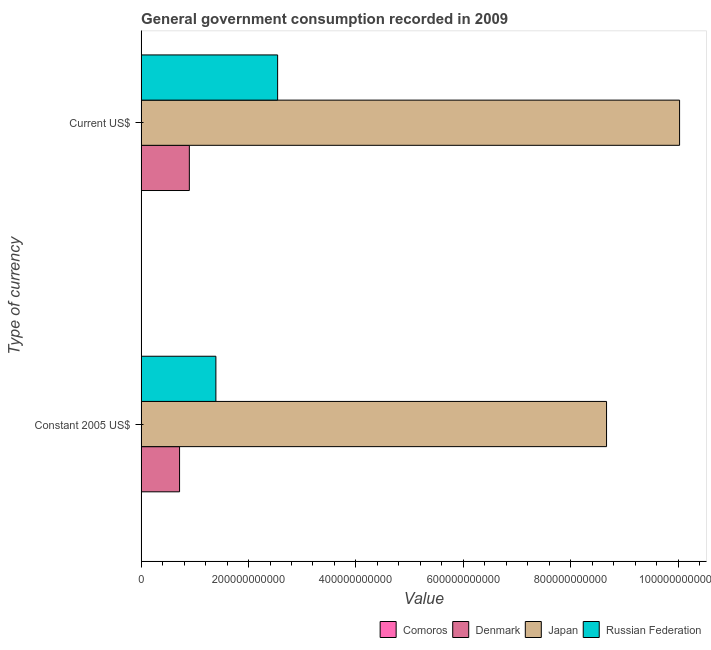How many different coloured bars are there?
Keep it short and to the point. 4. Are the number of bars on each tick of the Y-axis equal?
Your answer should be compact. Yes. How many bars are there on the 1st tick from the top?
Offer a very short reply. 4. How many bars are there on the 1st tick from the bottom?
Your response must be concise. 4. What is the label of the 2nd group of bars from the top?
Your answer should be compact. Constant 2005 US$. What is the value consumed in current us$ in Comoros?
Keep it short and to the point. 8.52e+07. Across all countries, what is the maximum value consumed in current us$?
Your response must be concise. 1.00e+12. Across all countries, what is the minimum value consumed in constant 2005 us$?
Give a very brief answer. 8.08e+07. In which country was the value consumed in current us$ minimum?
Offer a very short reply. Comoros. What is the total value consumed in constant 2005 us$ in the graph?
Offer a terse response. 1.08e+12. What is the difference between the value consumed in constant 2005 us$ in Comoros and that in Japan?
Provide a short and direct response. -8.67e+11. What is the difference between the value consumed in current us$ in Comoros and the value consumed in constant 2005 us$ in Japan?
Your answer should be very brief. -8.67e+11. What is the average value consumed in constant 2005 us$ per country?
Your answer should be very brief. 2.69e+11. What is the difference between the value consumed in constant 2005 us$ and value consumed in current us$ in Comoros?
Provide a short and direct response. -4.40e+06. What is the ratio of the value consumed in constant 2005 us$ in Russian Federation to that in Japan?
Keep it short and to the point. 0.16. In how many countries, is the value consumed in constant 2005 us$ greater than the average value consumed in constant 2005 us$ taken over all countries?
Your response must be concise. 1. What does the 1st bar from the top in Constant 2005 US$ represents?
Make the answer very short. Russian Federation. What does the 3rd bar from the bottom in Constant 2005 US$ represents?
Keep it short and to the point. Japan. How many bars are there?
Your response must be concise. 8. Are all the bars in the graph horizontal?
Your response must be concise. Yes. How many countries are there in the graph?
Your answer should be very brief. 4. What is the difference between two consecutive major ticks on the X-axis?
Keep it short and to the point. 2.00e+11. Does the graph contain any zero values?
Your response must be concise. No. Does the graph contain grids?
Make the answer very short. No. Where does the legend appear in the graph?
Your answer should be compact. Bottom right. What is the title of the graph?
Your answer should be compact. General government consumption recorded in 2009. Does "Ecuador" appear as one of the legend labels in the graph?
Your answer should be very brief. No. What is the label or title of the X-axis?
Your answer should be compact. Value. What is the label or title of the Y-axis?
Provide a short and direct response. Type of currency. What is the Value of Comoros in Constant 2005 US$?
Provide a short and direct response. 8.08e+07. What is the Value in Denmark in Constant 2005 US$?
Your response must be concise. 7.15e+1. What is the Value of Japan in Constant 2005 US$?
Make the answer very short. 8.67e+11. What is the Value of Russian Federation in Constant 2005 US$?
Offer a terse response. 1.39e+11. What is the Value in Comoros in Current US$?
Your response must be concise. 8.52e+07. What is the Value of Denmark in Current US$?
Your answer should be very brief. 8.97e+1. What is the Value in Japan in Current US$?
Make the answer very short. 1.00e+12. What is the Value in Russian Federation in Current US$?
Your answer should be very brief. 2.54e+11. Across all Type of currency, what is the maximum Value of Comoros?
Ensure brevity in your answer.  8.52e+07. Across all Type of currency, what is the maximum Value in Denmark?
Your answer should be compact. 8.97e+1. Across all Type of currency, what is the maximum Value in Japan?
Provide a succinct answer. 1.00e+12. Across all Type of currency, what is the maximum Value of Russian Federation?
Provide a short and direct response. 2.54e+11. Across all Type of currency, what is the minimum Value in Comoros?
Your answer should be compact. 8.08e+07. Across all Type of currency, what is the minimum Value of Denmark?
Offer a terse response. 7.15e+1. Across all Type of currency, what is the minimum Value in Japan?
Give a very brief answer. 8.67e+11. Across all Type of currency, what is the minimum Value in Russian Federation?
Your answer should be very brief. 1.39e+11. What is the total Value of Comoros in the graph?
Keep it short and to the point. 1.66e+08. What is the total Value in Denmark in the graph?
Ensure brevity in your answer.  1.61e+11. What is the total Value of Japan in the graph?
Ensure brevity in your answer.  1.87e+12. What is the total Value in Russian Federation in the graph?
Provide a short and direct response. 3.93e+11. What is the difference between the Value in Comoros in Constant 2005 US$ and that in Current US$?
Give a very brief answer. -4.40e+06. What is the difference between the Value in Denmark in Constant 2005 US$ and that in Current US$?
Provide a short and direct response. -1.82e+1. What is the difference between the Value of Japan in Constant 2005 US$ and that in Current US$?
Ensure brevity in your answer.  -1.36e+11. What is the difference between the Value in Russian Federation in Constant 2005 US$ and that in Current US$?
Your answer should be compact. -1.15e+11. What is the difference between the Value of Comoros in Constant 2005 US$ and the Value of Denmark in Current US$?
Provide a short and direct response. -8.97e+1. What is the difference between the Value of Comoros in Constant 2005 US$ and the Value of Japan in Current US$?
Provide a succinct answer. -1.00e+12. What is the difference between the Value in Comoros in Constant 2005 US$ and the Value in Russian Federation in Current US$?
Ensure brevity in your answer.  -2.54e+11. What is the difference between the Value in Denmark in Constant 2005 US$ and the Value in Japan in Current US$?
Your answer should be compact. -9.31e+11. What is the difference between the Value in Denmark in Constant 2005 US$ and the Value in Russian Federation in Current US$?
Ensure brevity in your answer.  -1.83e+11. What is the difference between the Value in Japan in Constant 2005 US$ and the Value in Russian Federation in Current US$?
Your response must be concise. 6.13e+11. What is the average Value in Comoros per Type of currency?
Your response must be concise. 8.30e+07. What is the average Value in Denmark per Type of currency?
Make the answer very short. 8.06e+1. What is the average Value of Japan per Type of currency?
Provide a succinct answer. 9.35e+11. What is the average Value in Russian Federation per Type of currency?
Your answer should be compact. 1.97e+11. What is the difference between the Value of Comoros and Value of Denmark in Constant 2005 US$?
Provide a short and direct response. -7.15e+1. What is the difference between the Value of Comoros and Value of Japan in Constant 2005 US$?
Your response must be concise. -8.67e+11. What is the difference between the Value of Comoros and Value of Russian Federation in Constant 2005 US$?
Give a very brief answer. -1.39e+11. What is the difference between the Value in Denmark and Value in Japan in Constant 2005 US$?
Keep it short and to the point. -7.95e+11. What is the difference between the Value in Denmark and Value in Russian Federation in Constant 2005 US$?
Offer a terse response. -6.77e+1. What is the difference between the Value of Japan and Value of Russian Federation in Constant 2005 US$?
Give a very brief answer. 7.27e+11. What is the difference between the Value in Comoros and Value in Denmark in Current US$?
Provide a succinct answer. -8.97e+1. What is the difference between the Value of Comoros and Value of Japan in Current US$?
Offer a terse response. -1.00e+12. What is the difference between the Value in Comoros and Value in Russian Federation in Current US$?
Your answer should be compact. -2.54e+11. What is the difference between the Value of Denmark and Value of Japan in Current US$?
Keep it short and to the point. -9.13e+11. What is the difference between the Value in Denmark and Value in Russian Federation in Current US$?
Provide a short and direct response. -1.64e+11. What is the difference between the Value in Japan and Value in Russian Federation in Current US$?
Provide a short and direct response. 7.49e+11. What is the ratio of the Value of Comoros in Constant 2005 US$ to that in Current US$?
Give a very brief answer. 0.95. What is the ratio of the Value in Denmark in Constant 2005 US$ to that in Current US$?
Give a very brief answer. 0.8. What is the ratio of the Value in Japan in Constant 2005 US$ to that in Current US$?
Provide a short and direct response. 0.86. What is the ratio of the Value in Russian Federation in Constant 2005 US$ to that in Current US$?
Provide a succinct answer. 0.55. What is the difference between the highest and the second highest Value in Comoros?
Keep it short and to the point. 4.40e+06. What is the difference between the highest and the second highest Value of Denmark?
Give a very brief answer. 1.82e+1. What is the difference between the highest and the second highest Value in Japan?
Provide a succinct answer. 1.36e+11. What is the difference between the highest and the second highest Value of Russian Federation?
Provide a succinct answer. 1.15e+11. What is the difference between the highest and the lowest Value in Comoros?
Your response must be concise. 4.40e+06. What is the difference between the highest and the lowest Value of Denmark?
Your answer should be compact. 1.82e+1. What is the difference between the highest and the lowest Value in Japan?
Ensure brevity in your answer.  1.36e+11. What is the difference between the highest and the lowest Value of Russian Federation?
Give a very brief answer. 1.15e+11. 